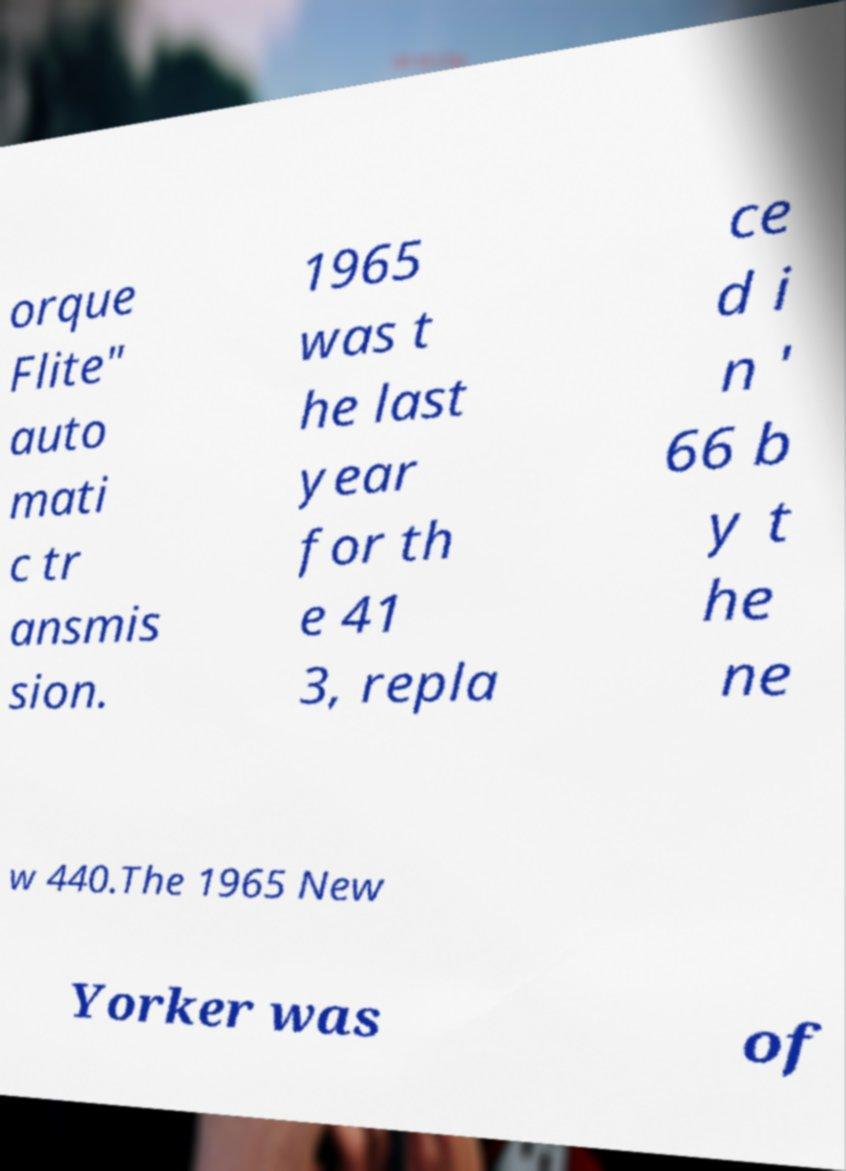Please read and relay the text visible in this image. What does it say? orque Flite" auto mati c tr ansmis sion. 1965 was t he last year for th e 41 3, repla ce d i n ' 66 b y t he ne w 440.The 1965 New Yorker was of 